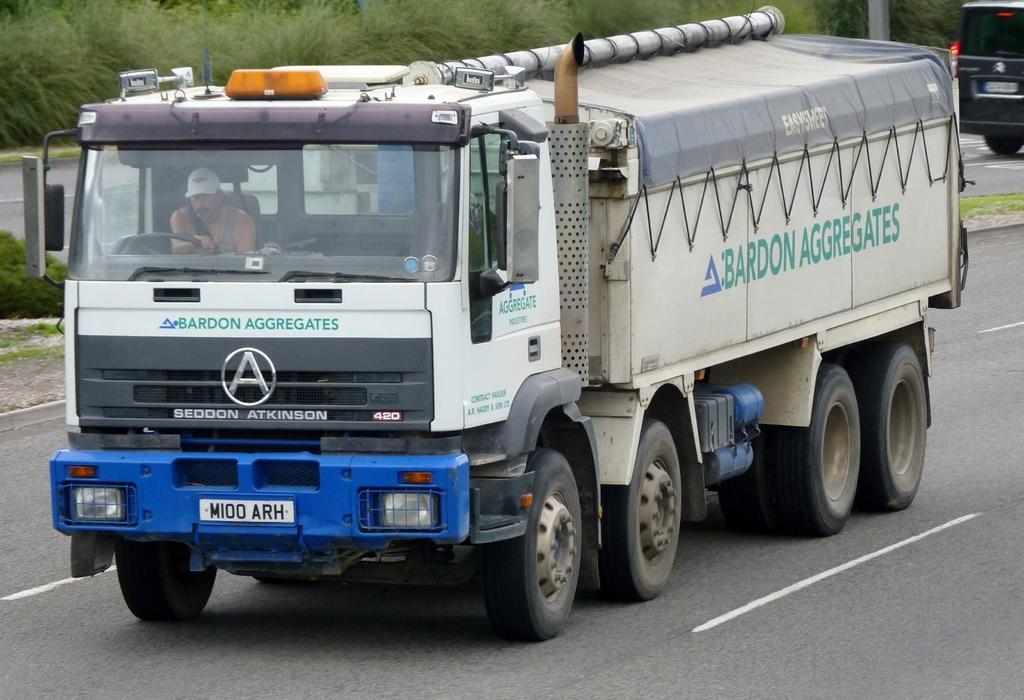What is the main subject of the image? The main subject of the image is a vehicle on the road. What can be seen in the background of the image? There is greenery grass in the background. How many hearts can be seen in the image? There are no hearts visible in the image. 